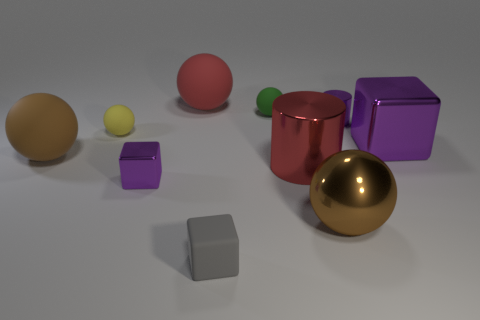Are there any brown rubber balls?
Offer a terse response. Yes. There is a yellow rubber ball; are there any brown rubber balls right of it?
Your answer should be compact. No. There is a big thing that is the same shape as the small gray object; what is its material?
Provide a succinct answer. Metal. Is there anything else that is made of the same material as the yellow thing?
Provide a succinct answer. Yes. How many other objects are there of the same shape as the large red shiny object?
Ensure brevity in your answer.  1. What number of big spheres are behind the purple cube on the left side of the brown object to the right of the red metallic cylinder?
Make the answer very short. 2. How many other big red rubber things are the same shape as the red rubber thing?
Offer a very short reply. 0. There is a metallic block right of the rubber cube; is it the same color as the tiny metallic cylinder?
Keep it short and to the point. Yes. The matte object in front of the purple metal cube in front of the big red cylinder right of the big brown rubber sphere is what shape?
Keep it short and to the point. Cube. There is a red metal thing; does it have the same size as the sphere that is on the right side of the tiny green rubber object?
Make the answer very short. Yes. 